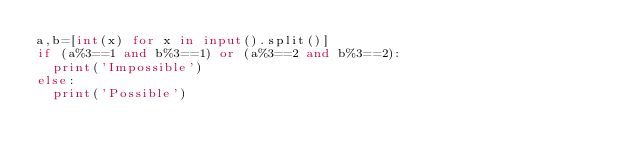<code> <loc_0><loc_0><loc_500><loc_500><_Python_>a,b=[int(x) for x in input().split()]
if (a%3==1 and b%3==1) or (a%3==2 and b%3==2):
  print('Impossible')
else:
  print('Possible')</code> 